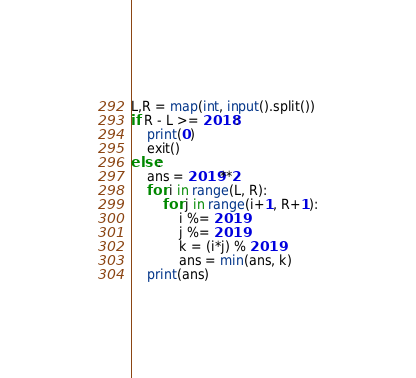<code> <loc_0><loc_0><loc_500><loc_500><_Python_>L,R = map(int, input().split())
if R - L >= 2018:
    print(0)
    exit()
else:
    ans = 2019**2
    for i in range(L, R):
        for j in range(i+1, R+1):
            i %= 2019
            j %= 2019
            k = (i*j) % 2019
            ans = min(ans, k)
    print(ans)</code> 